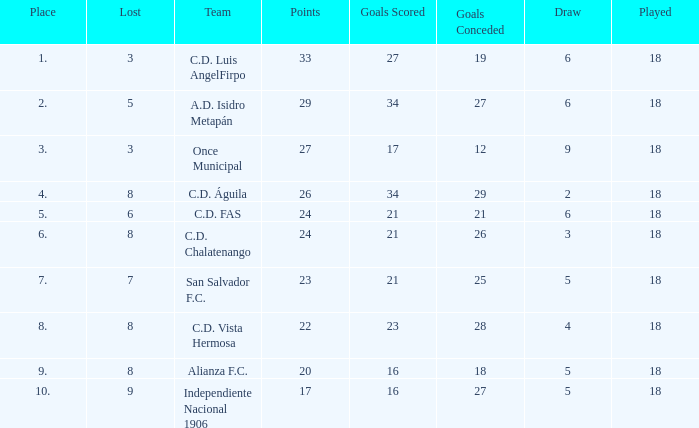For Once Municipal, what were the goals scored that had less than 27 points and greater than place 1? None. 